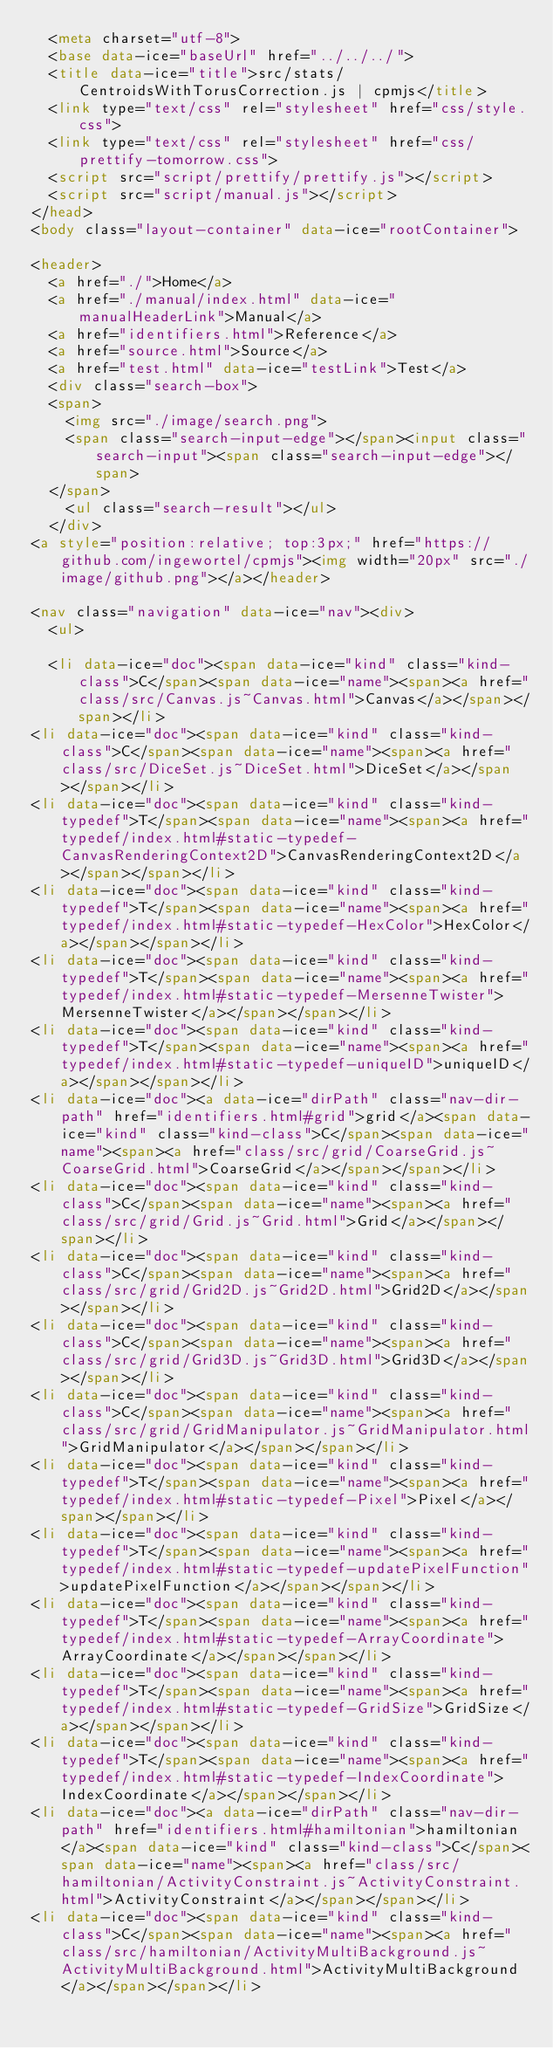<code> <loc_0><loc_0><loc_500><loc_500><_HTML_>  <meta charset="utf-8">
  <base data-ice="baseUrl" href="../../../">
  <title data-ice="title">src/stats/CentroidsWithTorusCorrection.js | cpmjs</title>
  <link type="text/css" rel="stylesheet" href="css/style.css">
  <link type="text/css" rel="stylesheet" href="css/prettify-tomorrow.css">
  <script src="script/prettify/prettify.js"></script>
  <script src="script/manual.js"></script>
</head>
<body class="layout-container" data-ice="rootContainer">

<header>
  <a href="./">Home</a>
  <a href="./manual/index.html" data-ice="manualHeaderLink">Manual</a>
  <a href="identifiers.html">Reference</a>
  <a href="source.html">Source</a>
  <a href="test.html" data-ice="testLink">Test</a>
  <div class="search-box">
  <span>
    <img src="./image/search.png">
    <span class="search-input-edge"></span><input class="search-input"><span class="search-input-edge"></span>
  </span>
    <ul class="search-result"></ul>
  </div>
<a style="position:relative; top:3px;" href="https://github.com/ingewortel/cpmjs"><img width="20px" src="./image/github.png"></a></header>

<nav class="navigation" data-ice="nav"><div>
  <ul>
    
  <li data-ice="doc"><span data-ice="kind" class="kind-class">C</span><span data-ice="name"><span><a href="class/src/Canvas.js~Canvas.html">Canvas</a></span></span></li>
<li data-ice="doc"><span data-ice="kind" class="kind-class">C</span><span data-ice="name"><span><a href="class/src/DiceSet.js~DiceSet.html">DiceSet</a></span></span></li>
<li data-ice="doc"><span data-ice="kind" class="kind-typedef">T</span><span data-ice="name"><span><a href="typedef/index.html#static-typedef-CanvasRenderingContext2D">CanvasRenderingContext2D</a></span></span></li>
<li data-ice="doc"><span data-ice="kind" class="kind-typedef">T</span><span data-ice="name"><span><a href="typedef/index.html#static-typedef-HexColor">HexColor</a></span></span></li>
<li data-ice="doc"><span data-ice="kind" class="kind-typedef">T</span><span data-ice="name"><span><a href="typedef/index.html#static-typedef-MersenneTwister">MersenneTwister</a></span></span></li>
<li data-ice="doc"><span data-ice="kind" class="kind-typedef">T</span><span data-ice="name"><span><a href="typedef/index.html#static-typedef-uniqueID">uniqueID</a></span></span></li>
<li data-ice="doc"><a data-ice="dirPath" class="nav-dir-path" href="identifiers.html#grid">grid</a><span data-ice="kind" class="kind-class">C</span><span data-ice="name"><span><a href="class/src/grid/CoarseGrid.js~CoarseGrid.html">CoarseGrid</a></span></span></li>
<li data-ice="doc"><span data-ice="kind" class="kind-class">C</span><span data-ice="name"><span><a href="class/src/grid/Grid.js~Grid.html">Grid</a></span></span></li>
<li data-ice="doc"><span data-ice="kind" class="kind-class">C</span><span data-ice="name"><span><a href="class/src/grid/Grid2D.js~Grid2D.html">Grid2D</a></span></span></li>
<li data-ice="doc"><span data-ice="kind" class="kind-class">C</span><span data-ice="name"><span><a href="class/src/grid/Grid3D.js~Grid3D.html">Grid3D</a></span></span></li>
<li data-ice="doc"><span data-ice="kind" class="kind-class">C</span><span data-ice="name"><span><a href="class/src/grid/GridManipulator.js~GridManipulator.html">GridManipulator</a></span></span></li>
<li data-ice="doc"><span data-ice="kind" class="kind-typedef">T</span><span data-ice="name"><span><a href="typedef/index.html#static-typedef-Pixel">Pixel</a></span></span></li>
<li data-ice="doc"><span data-ice="kind" class="kind-typedef">T</span><span data-ice="name"><span><a href="typedef/index.html#static-typedef-updatePixelFunction">updatePixelFunction</a></span></span></li>
<li data-ice="doc"><span data-ice="kind" class="kind-typedef">T</span><span data-ice="name"><span><a href="typedef/index.html#static-typedef-ArrayCoordinate">ArrayCoordinate</a></span></span></li>
<li data-ice="doc"><span data-ice="kind" class="kind-typedef">T</span><span data-ice="name"><span><a href="typedef/index.html#static-typedef-GridSize">GridSize</a></span></span></li>
<li data-ice="doc"><span data-ice="kind" class="kind-typedef">T</span><span data-ice="name"><span><a href="typedef/index.html#static-typedef-IndexCoordinate">IndexCoordinate</a></span></span></li>
<li data-ice="doc"><a data-ice="dirPath" class="nav-dir-path" href="identifiers.html#hamiltonian">hamiltonian</a><span data-ice="kind" class="kind-class">C</span><span data-ice="name"><span><a href="class/src/hamiltonian/ActivityConstraint.js~ActivityConstraint.html">ActivityConstraint</a></span></span></li>
<li data-ice="doc"><span data-ice="kind" class="kind-class">C</span><span data-ice="name"><span><a href="class/src/hamiltonian/ActivityMultiBackground.js~ActivityMultiBackground.html">ActivityMultiBackground</a></span></span></li></code> 